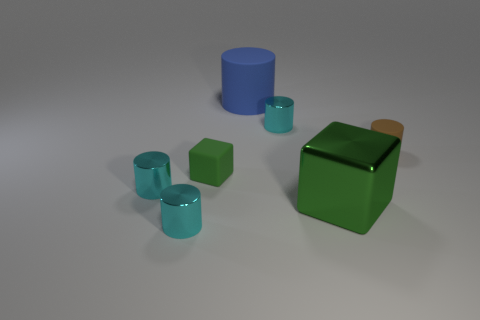There is another cube that is the same color as the small cube; what material is it?
Your response must be concise. Metal. Do the small matte object that is to the right of the green rubber thing and the large green thing have the same shape?
Your answer should be compact. No. How many things are either brown rubber objects or small objects that are in front of the small brown rubber thing?
Give a very brief answer. 4. Is the material of the large thing to the left of the large metallic thing the same as the small brown object?
Your answer should be very brief. Yes. What is the tiny green cube that is behind the cylinder that is in front of the big green shiny thing made of?
Offer a very short reply. Rubber. Are there more small brown rubber things that are right of the big blue cylinder than brown objects that are behind the tiny brown object?
Keep it short and to the point. Yes. What is the size of the green metal object?
Provide a succinct answer. Large. Do the tiny matte object that is to the left of the big metallic cube and the big shiny cube have the same color?
Your response must be concise. Yes. Is there a tiny matte object left of the green object on the right side of the blue rubber cylinder?
Provide a short and direct response. Yes. Are there fewer green blocks that are behind the large blue cylinder than tiny metal things that are behind the tiny brown cylinder?
Your answer should be very brief. Yes. 